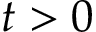<formula> <loc_0><loc_0><loc_500><loc_500>t > 0</formula> 